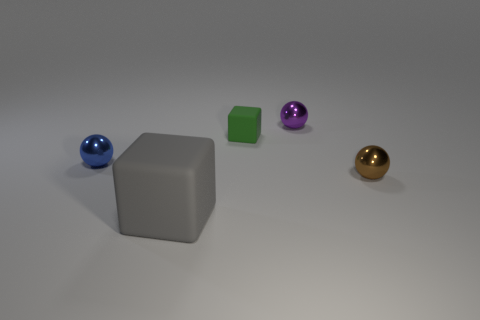There is a rubber thing in front of the ball that is left of the gray matte object; is there a metal object right of it?
Your response must be concise. Yes. There is a thing that is made of the same material as the small green cube; what size is it?
Provide a succinct answer. Large. There is a big block; are there any small objects to the left of it?
Your answer should be compact. Yes. There is a small shiny thing that is on the left side of the purple shiny object; is there a gray rubber object that is right of it?
Make the answer very short. Yes. There is a block that is to the right of the gray cube; is its size the same as the shiny object to the left of the purple ball?
Your answer should be compact. Yes. How many big objects are green matte things or purple metal things?
Your answer should be very brief. 0. What is the material of the tiny object to the right of the sphere that is behind the tiny blue metallic sphere?
Offer a very short reply. Metal. Is there a tiny brown sphere that has the same material as the small blue thing?
Your answer should be very brief. Yes. Is the small purple ball made of the same material as the sphere that is in front of the blue object?
Ensure brevity in your answer.  Yes. There is a cube that is the same size as the brown metallic thing; what is its color?
Your response must be concise. Green. 